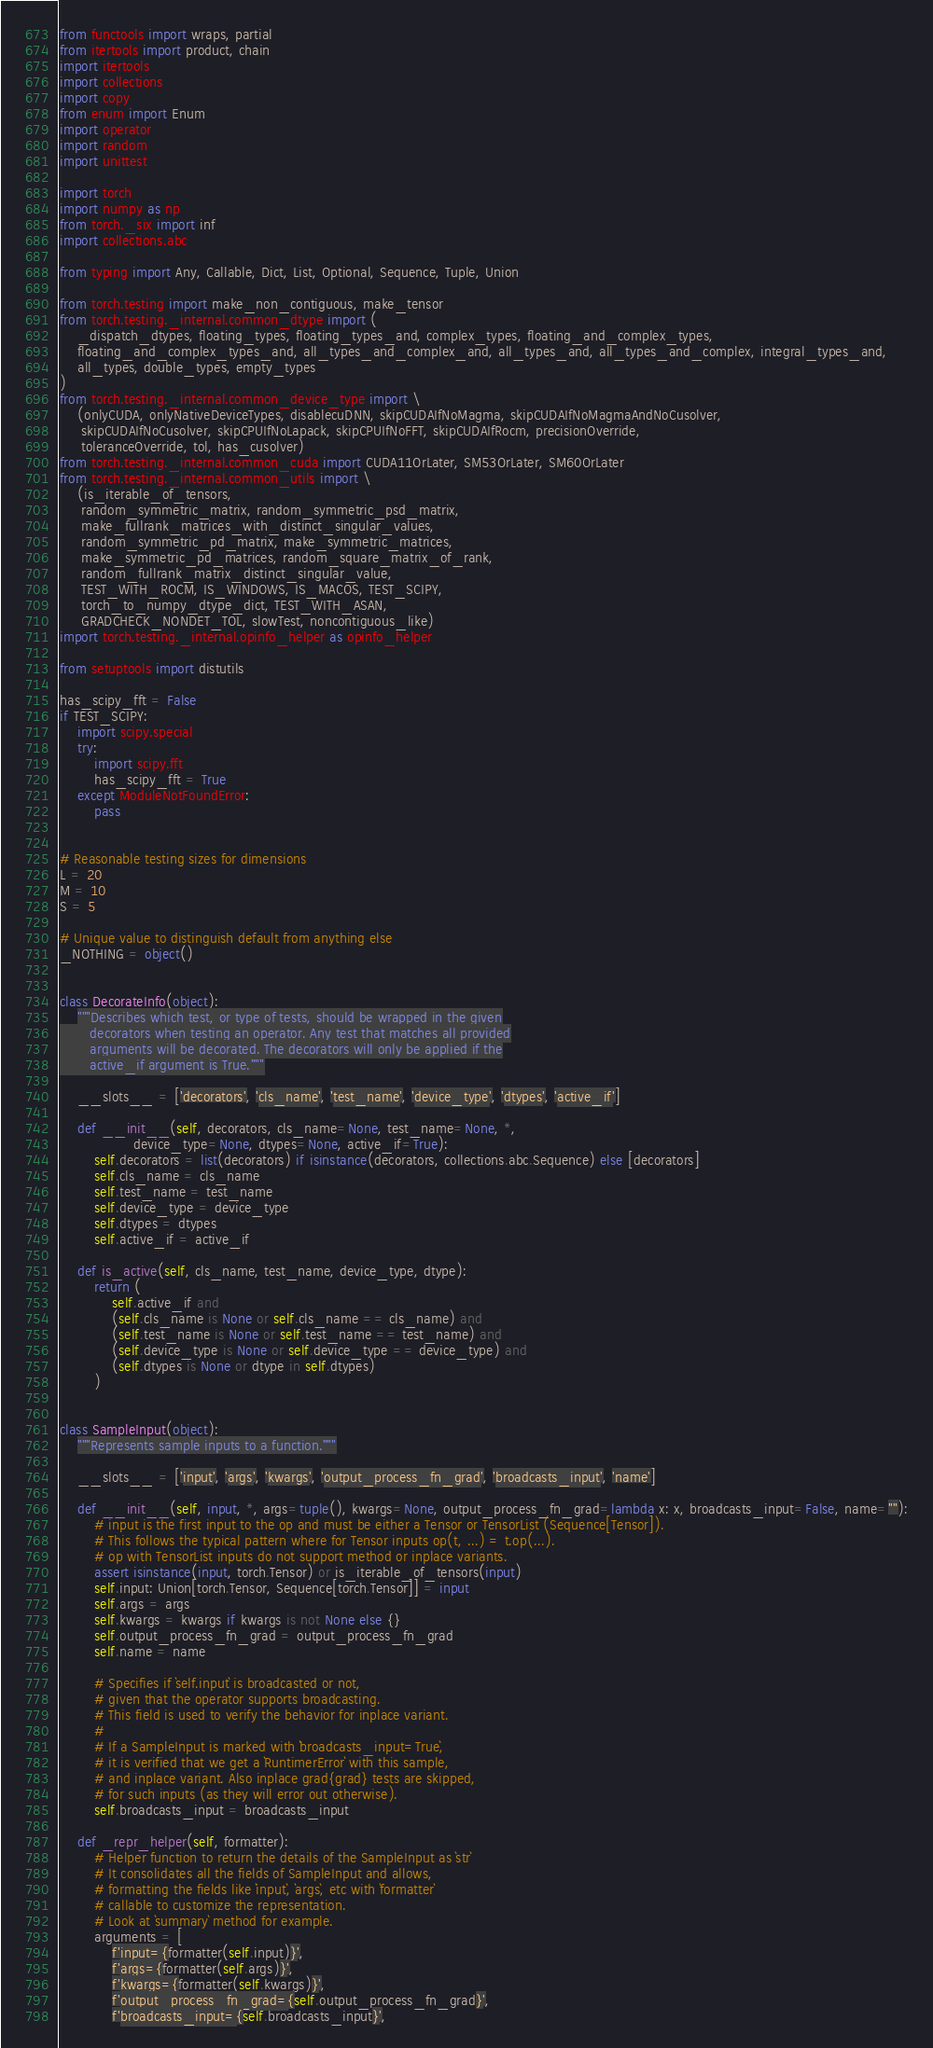<code> <loc_0><loc_0><loc_500><loc_500><_Python_>from functools import wraps, partial
from itertools import product, chain
import itertools
import collections
import copy
from enum import Enum
import operator
import random
import unittest

import torch
import numpy as np
from torch._six import inf
import collections.abc

from typing import Any, Callable, Dict, List, Optional, Sequence, Tuple, Union

from torch.testing import make_non_contiguous, make_tensor
from torch.testing._internal.common_dtype import (
    _dispatch_dtypes, floating_types, floating_types_and, complex_types, floating_and_complex_types,
    floating_and_complex_types_and, all_types_and_complex_and, all_types_and, all_types_and_complex, integral_types_and,
    all_types, double_types, empty_types
)
from torch.testing._internal.common_device_type import \
    (onlyCUDA, onlyNativeDeviceTypes, disablecuDNN, skipCUDAIfNoMagma, skipCUDAIfNoMagmaAndNoCusolver,
     skipCUDAIfNoCusolver, skipCPUIfNoLapack, skipCPUIfNoFFT, skipCUDAIfRocm, precisionOverride,
     toleranceOverride, tol, has_cusolver)
from torch.testing._internal.common_cuda import CUDA11OrLater, SM53OrLater, SM60OrLater
from torch.testing._internal.common_utils import \
    (is_iterable_of_tensors,
     random_symmetric_matrix, random_symmetric_psd_matrix,
     make_fullrank_matrices_with_distinct_singular_values,
     random_symmetric_pd_matrix, make_symmetric_matrices,
     make_symmetric_pd_matrices, random_square_matrix_of_rank,
     random_fullrank_matrix_distinct_singular_value,
     TEST_WITH_ROCM, IS_WINDOWS, IS_MACOS, TEST_SCIPY,
     torch_to_numpy_dtype_dict, TEST_WITH_ASAN,
     GRADCHECK_NONDET_TOL, slowTest, noncontiguous_like)
import torch.testing._internal.opinfo_helper as opinfo_helper

from setuptools import distutils

has_scipy_fft = False
if TEST_SCIPY:
    import scipy.special
    try:
        import scipy.fft
        has_scipy_fft = True
    except ModuleNotFoundError:
        pass


# Reasonable testing sizes for dimensions
L = 20
M = 10
S = 5

# Unique value to distinguish default from anything else
_NOTHING = object()


class DecorateInfo(object):
    """Describes which test, or type of tests, should be wrapped in the given
       decorators when testing an operator. Any test that matches all provided
       arguments will be decorated. The decorators will only be applied if the
       active_if argument is True."""

    __slots__ = ['decorators', 'cls_name', 'test_name', 'device_type', 'dtypes', 'active_if']

    def __init__(self, decorators, cls_name=None, test_name=None, *,
                 device_type=None, dtypes=None, active_if=True):
        self.decorators = list(decorators) if isinstance(decorators, collections.abc.Sequence) else [decorators]
        self.cls_name = cls_name
        self.test_name = test_name
        self.device_type = device_type
        self.dtypes = dtypes
        self.active_if = active_if

    def is_active(self, cls_name, test_name, device_type, dtype):
        return (
            self.active_if and
            (self.cls_name is None or self.cls_name == cls_name) and
            (self.test_name is None or self.test_name == test_name) and
            (self.device_type is None or self.device_type == device_type) and
            (self.dtypes is None or dtype in self.dtypes)
        )


class SampleInput(object):
    """Represents sample inputs to a function."""

    __slots__ = ['input', 'args', 'kwargs', 'output_process_fn_grad', 'broadcasts_input', 'name']

    def __init__(self, input, *, args=tuple(), kwargs=None, output_process_fn_grad=lambda x: x, broadcasts_input=False, name=""):
        # input is the first input to the op and must be either a Tensor or TensorList (Sequence[Tensor]).
        # This follows the typical pattern where for Tensor inputs op(t, ...) = t.op(...).
        # op with TensorList inputs do not support method or inplace variants.
        assert isinstance(input, torch.Tensor) or is_iterable_of_tensors(input)
        self.input: Union[torch.Tensor, Sequence[torch.Tensor]] = input
        self.args = args
        self.kwargs = kwargs if kwargs is not None else {}
        self.output_process_fn_grad = output_process_fn_grad
        self.name = name

        # Specifies if `self.input` is broadcasted or not,
        # given that the operator supports broadcasting.
        # This field is used to verify the behavior for inplace variant.
        #
        # If a SampleInput is marked with `broadcasts_input=True`,
        # it is verified that we get a `RuntimerError` with this sample,
        # and inplace variant. Also inplace grad{grad} tests are skipped,
        # for such inputs (as they will error out otherwise).
        self.broadcasts_input = broadcasts_input

    def _repr_helper(self, formatter):
        # Helper function to return the details of the SampleInput as `str`
        # It consolidates all the fields of SampleInput and allows,
        # formatting the fields like `input`, `args`, etc with `formatter`
        # callable to customize the representation.
        # Look at `summary` method for example.
        arguments = [
            f'input={formatter(self.input)}',
            f'args={formatter(self.args)}',
            f'kwargs={formatter(self.kwargs)}',
            f'output_process_fn_grad={self.output_process_fn_grad}',
            f'broadcasts_input={self.broadcasts_input}',</code> 